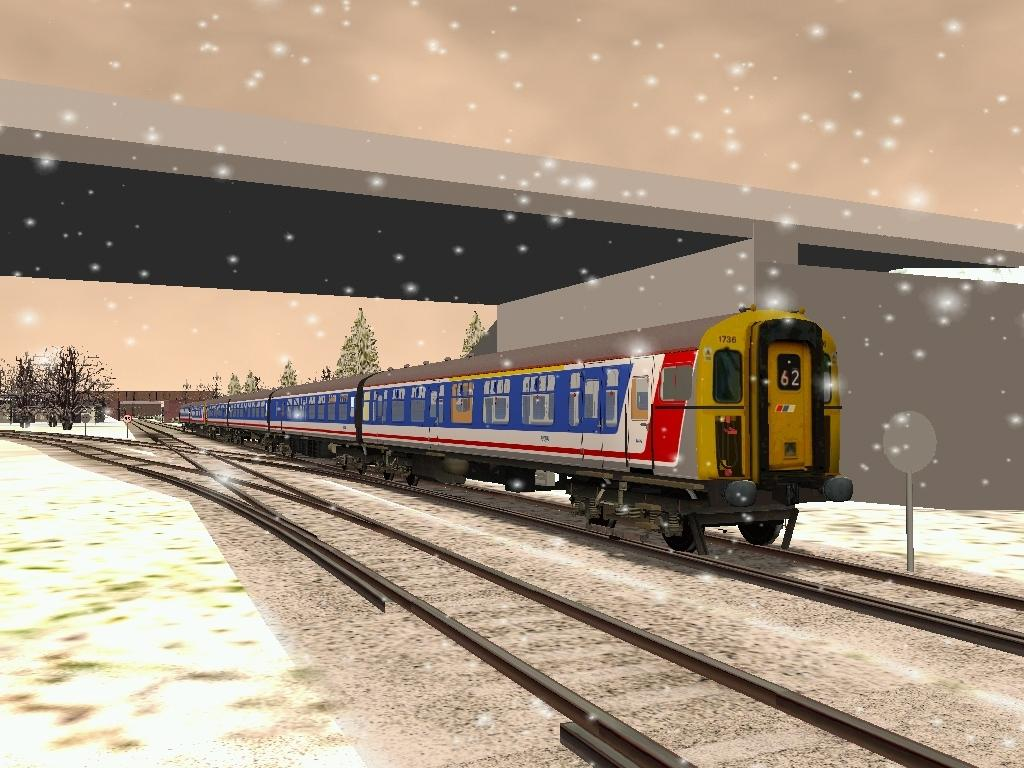What type of picture is the image? The image is an animated picture. What can be seen on the track in the image? There is a train on the track in the image. What is present near the track in the image? There is a signboard and poles in the image. What type of vegetation is visible in the image? There is a group of trees in the image. What type of structure is present in the image? There is a wall in the image. What can be seen in the sky in the image? There are stars visible in the image. What type of trousers is the train wearing in the image? Trains do not wear trousers, as they are inanimate objects. Where is the meeting taking place in the image? There is no meeting depicted in the image. 